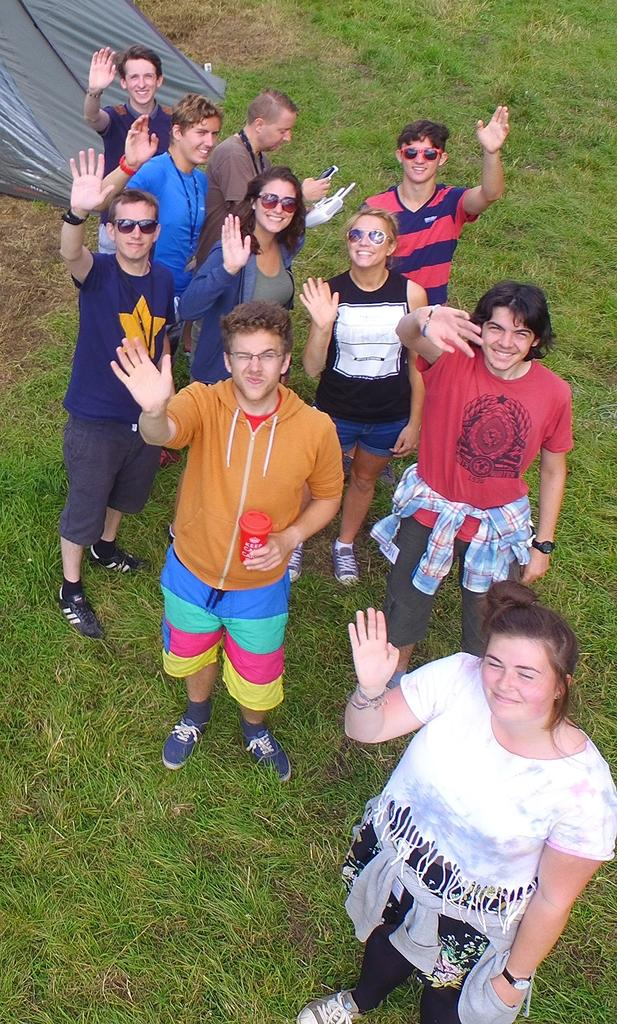What is the main subject of the image? The main subject of the image is a group of people. Where are the people located in the image? The people are standing on the grass. Can you describe the expressions of the people in the image? Some people in the group are smiling. What can be seen in the left side top corner of the image? There is a tent in the left side top corner of the image. How many sinks can be seen in the image? There are no sinks present in the image. What type of edge is visible in the image? There is no specific edge mentioned in the image; it features a group of people standing on grass with a tent in the background. 